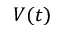<formula> <loc_0><loc_0><loc_500><loc_500>V ( t )</formula> 